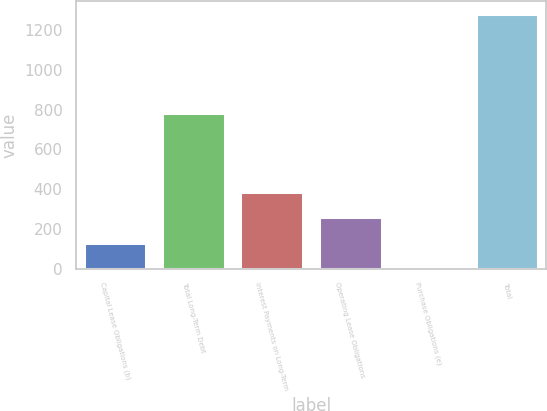Convert chart to OTSL. <chart><loc_0><loc_0><loc_500><loc_500><bar_chart><fcel>Capital Lease Obligations (b)<fcel>Total Long-Term Debt<fcel>Interest Payments on Long-Term<fcel>Operating Lease Obligations<fcel>Purchase Obligations (e)<fcel>Total<nl><fcel>129.19<fcel>781<fcel>385.17<fcel>257.18<fcel>1.2<fcel>1281.1<nl></chart> 